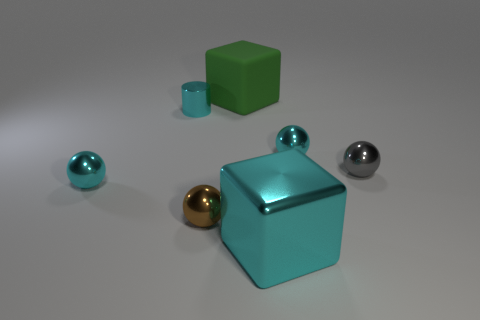What material is the cylinder that is the same color as the shiny cube?
Give a very brief answer. Metal. How many other objects are the same color as the tiny shiny cylinder?
Your response must be concise. 3. There is a large metallic thing; is it the same color as the small shiny sphere to the left of the tiny brown metallic thing?
Keep it short and to the point. Yes. There is another big thing that is the same shape as the matte thing; what is its color?
Ensure brevity in your answer.  Cyan. Does the cyan cylinder have the same material as the large thing to the right of the green cube?
Your answer should be compact. Yes. What is the color of the shiny cylinder?
Your answer should be compact. Cyan. There is a big cube left of the large cyan metal thing that is in front of the block that is behind the brown shiny ball; what is its color?
Your answer should be compact. Green. There is a small gray object; is it the same shape as the small cyan metal object that is to the right of the big metallic block?
Your answer should be very brief. Yes. What color is the sphere that is both in front of the tiny gray metallic sphere and on the right side of the small shiny cylinder?
Offer a terse response. Brown. Are there any gray rubber things of the same shape as the green matte thing?
Offer a very short reply. No. 